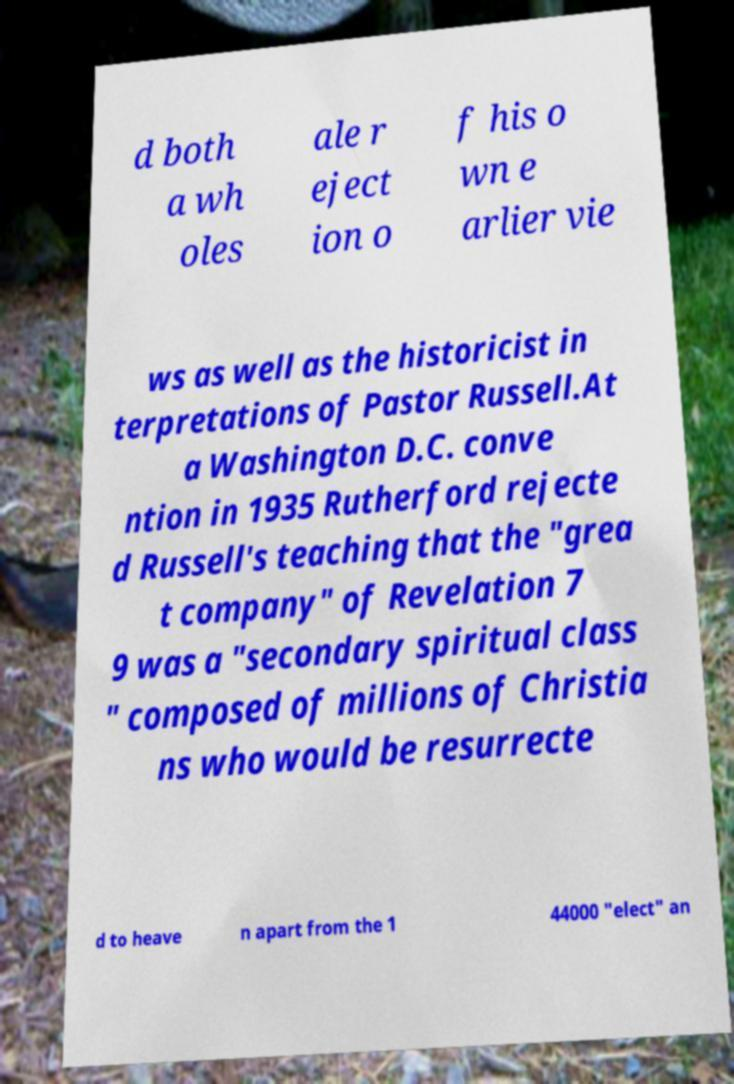For documentation purposes, I need the text within this image transcribed. Could you provide that? d both a wh oles ale r eject ion o f his o wn e arlier vie ws as well as the historicist in terpretations of Pastor Russell.At a Washington D.C. conve ntion in 1935 Rutherford rejecte d Russell's teaching that the "grea t company" of Revelation 7 9 was a "secondary spiritual class " composed of millions of Christia ns who would be resurrecte d to heave n apart from the 1 44000 "elect" an 